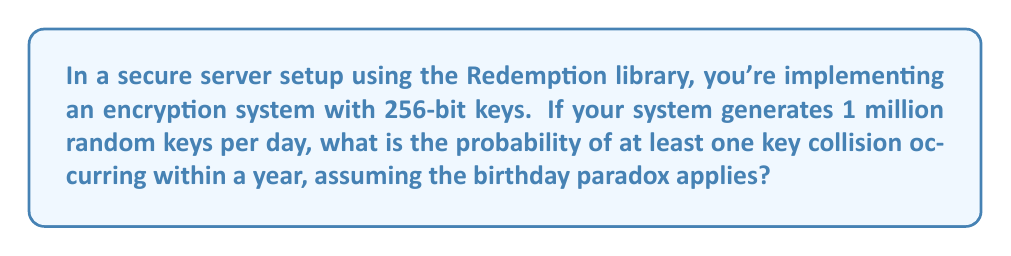Solve this math problem. Let's approach this step-by-step:

1) First, we need to calculate the total number of possible 256-bit keys:
   $N = 2^{256}$

2) Next, we need to determine the number of keys generated in a year:
   $n = 1,000,000 \times 365 = 365,000,000$

3) The birthday paradox gives us the probability of at least one collision:
   $P(\text{at least one collision}) = 1 - P(\text{no collisions})$

4) The probability of no collisions is:
   $$P(\text{no collisions}) = \frac{N!}{N^n(N-n)!}$$

5) However, this is computationally infeasible for large numbers. We can approximate it using the exponential function:
   $$P(\text{no collisions}) \approx e^{-\frac{n(n-1)}{2N}}$$

6) Substituting our values:
   $$P(\text{no collisions}) \approx e^{-\frac{365,000,000(365,000,000-1)}{2 \times 2^{256}}}$$

7) Simplifying:
   $$P(\text{no collisions}) \approx e^{-\frac{1.33225 \times 10^{17}}{2^{257}}} \approx e^{-9.15 \times 10^{-60}}$$

8) This is extremely close to 1, so:
   $P(\text{at least one collision}) = 1 - P(\text{no collisions}) \approx 9.15 \times 10^{-60}$
Answer: $9.15 \times 10^{-60}$ 